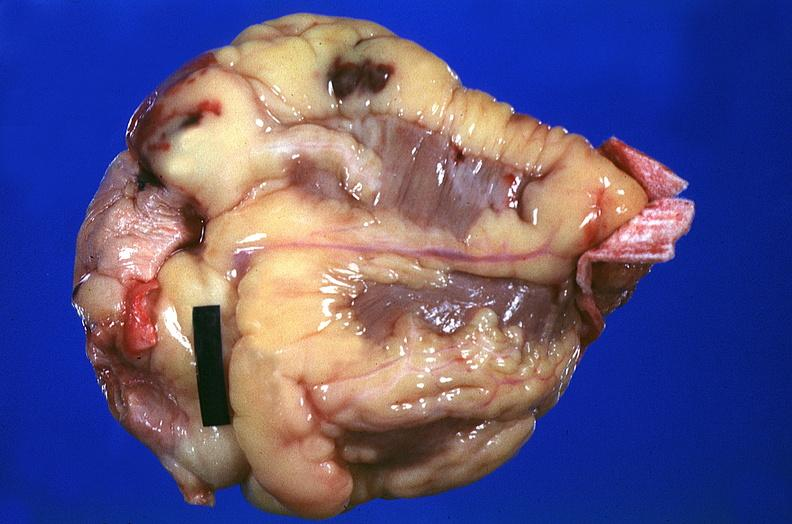s this photo of infant from head to toe present?
Answer the question using a single word or phrase. No 